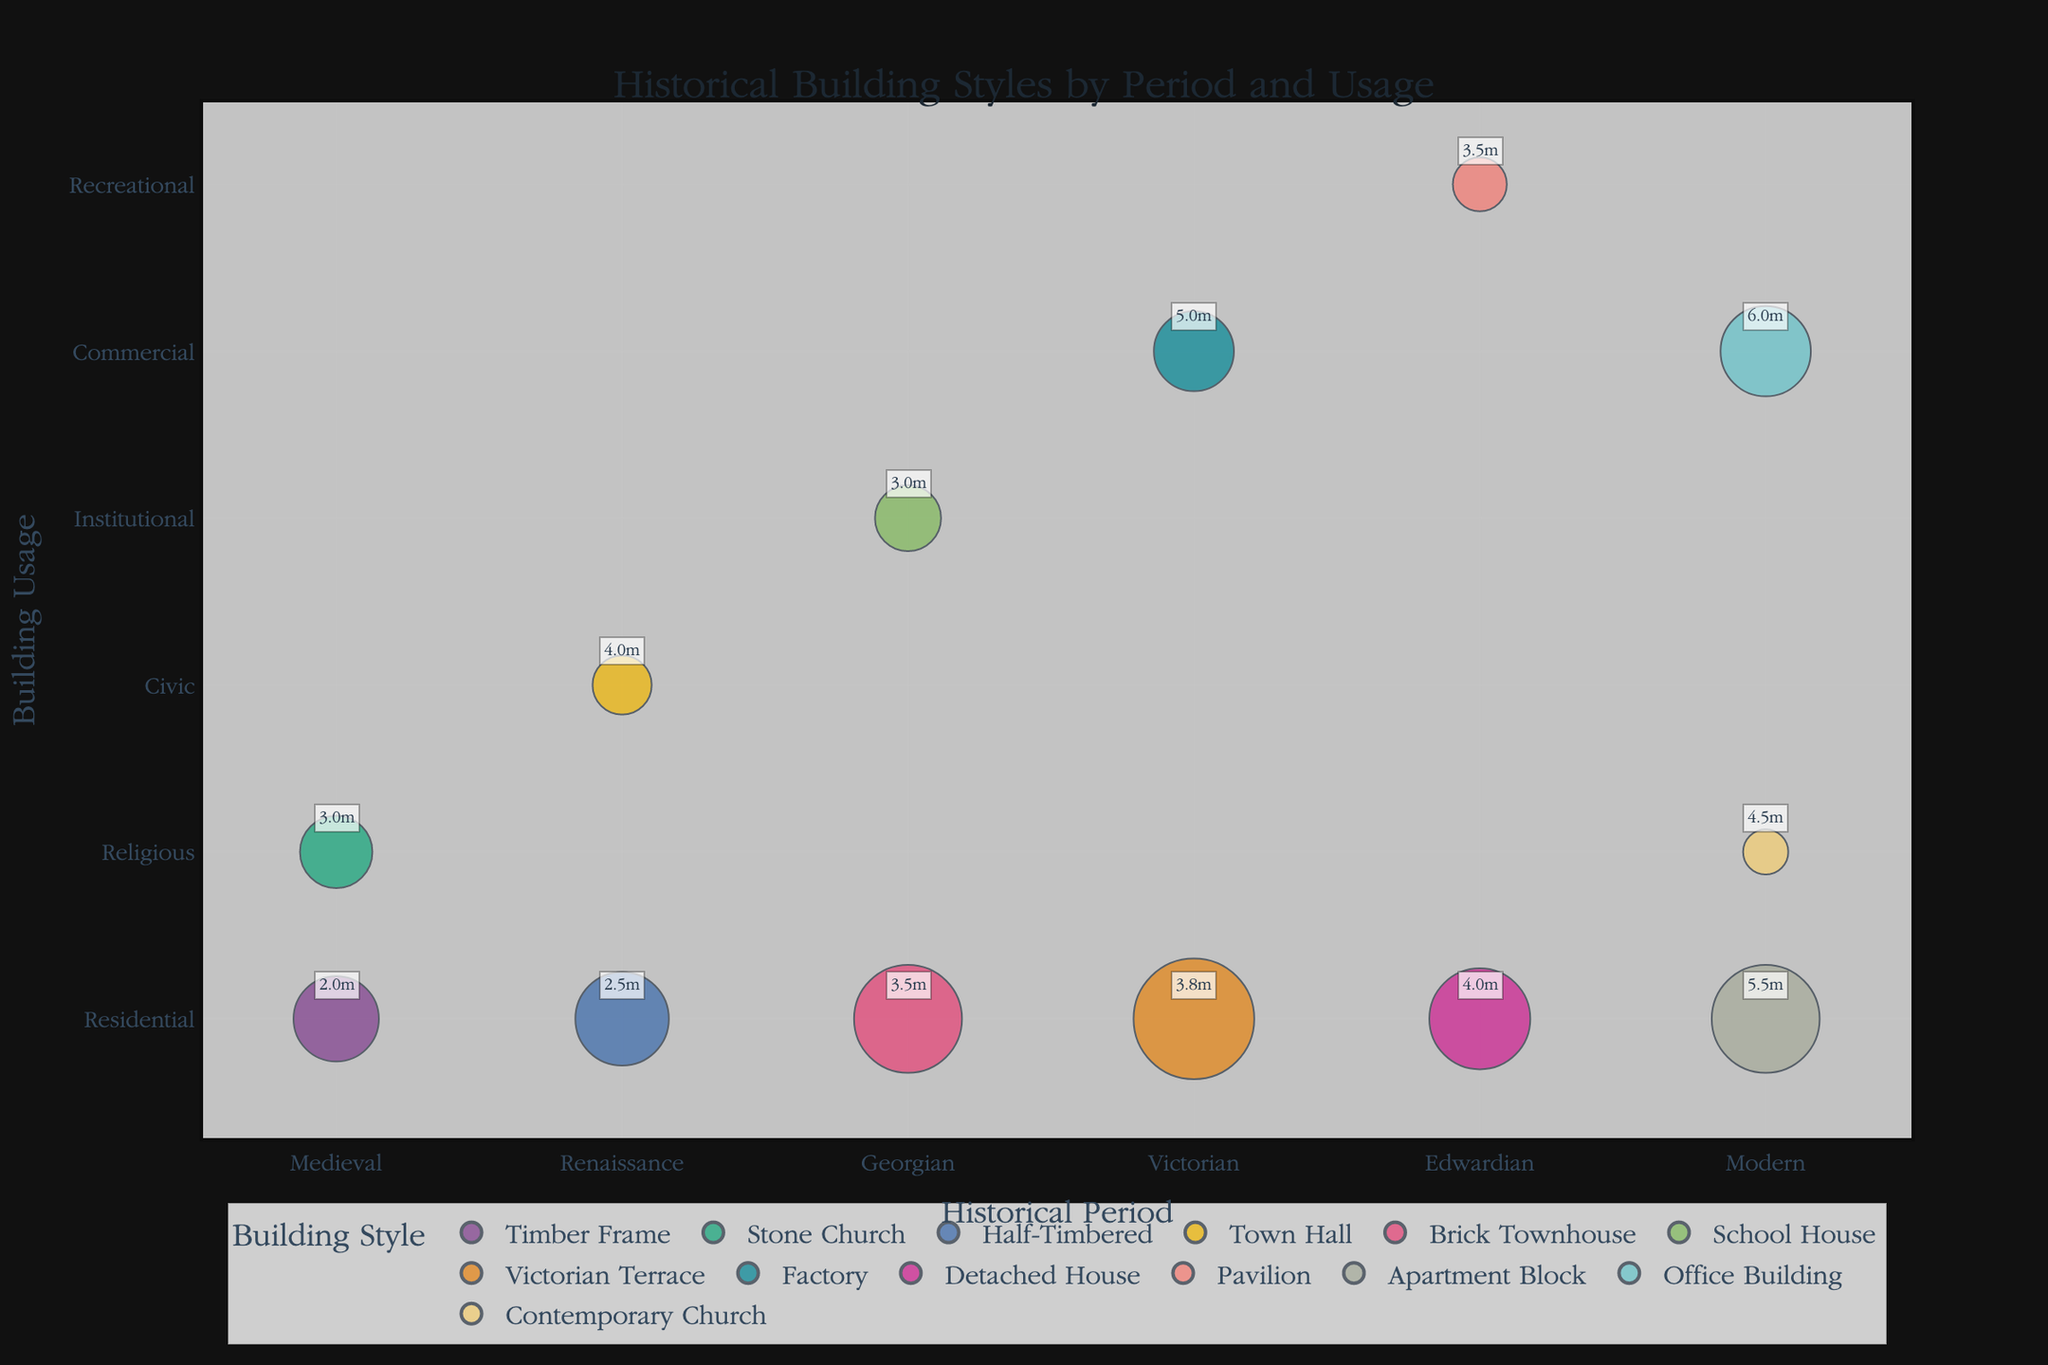what does the title of the chart indicate? The title "Historical Building Styles by Period and Usage" gives us an overview that the chart categorizes different building styles based on historical periods and their usage.
Answer: Historical Building Styles by Period and Usage How many different periods are represented in the chart? By looking at the x-axis labeled "Historical Period," we note distinct periods: Medieval, Renaissance, Georgian, Victorian, Edwardian, and Modern. Count these to get the total number.
Answer: 6 What is the usage category with the largest number of examples for the Modern period? For the Modern period, the chart has three usage categories: Residential, Commercial, and Religious. Among these, the bubbles indicating the number of examples show that the Residential (Apartment Block) has the largest size bubble.
Answer: Residential Which building style has the greatest average height, and what is its height? By examining the annotations on each bubble, we look for the highest numeric value. The Office Building in the Modern period has the tallest average height with an annotated value of 6 meters.
Answer: Office Building, 6m Which periods have examples of religious buildings, and what are their average heights? You find the Religious usage category and locate the associated periods: Medieval (Stone Church), and Modern (Contemporary Church). The respective average heights from the annotations are 3m and 4.5m.
Answer: Medieval - 3m, Modern - 4.5m Compare the number of examples for residential building styles from the Victorian and Edwardian periods. Which period has more examples? Locate the Residential usage category in both periods. The Victorian period has 50 examples (Victorian Terrace), while the Edwardian period has 35 examples (Detached House). Thus, the Victorian period has more.
Answer: Victorian Which contains more total buildings: the Georgian period's Residential usage or the Victorian period's Commercial usage? Sum the number of examples for each usage category within each period. Georgian Residential (Brick Townhouse) has 40 examples. Victorian Commercial (Factory) has 22 examples. Compare these totals.
Answer: Georgian Residential What is the building style with the smallest average height, and in what period and usage is it found? We look for the smallest annotated average height figure. The Timber Frame building style has an average height of 2 meters, found in the Medieval period under Residential usage.
Answer: Timber Frame, Medieval, Residential How many building styles exist in the Residential usage category across all periods, and what are they? By scanning through the Residential category across different periods, we count the unique building styles listed: Timber Frame, Half-Timbered, Brick Townhouse, Victorian Terrace, Detached House, and Apartment Block.
Answer: 6 (Timber Frame, Half-Timbered, Brick Townhouse, Victorian Terrace, Detached House, Apartment Block) 